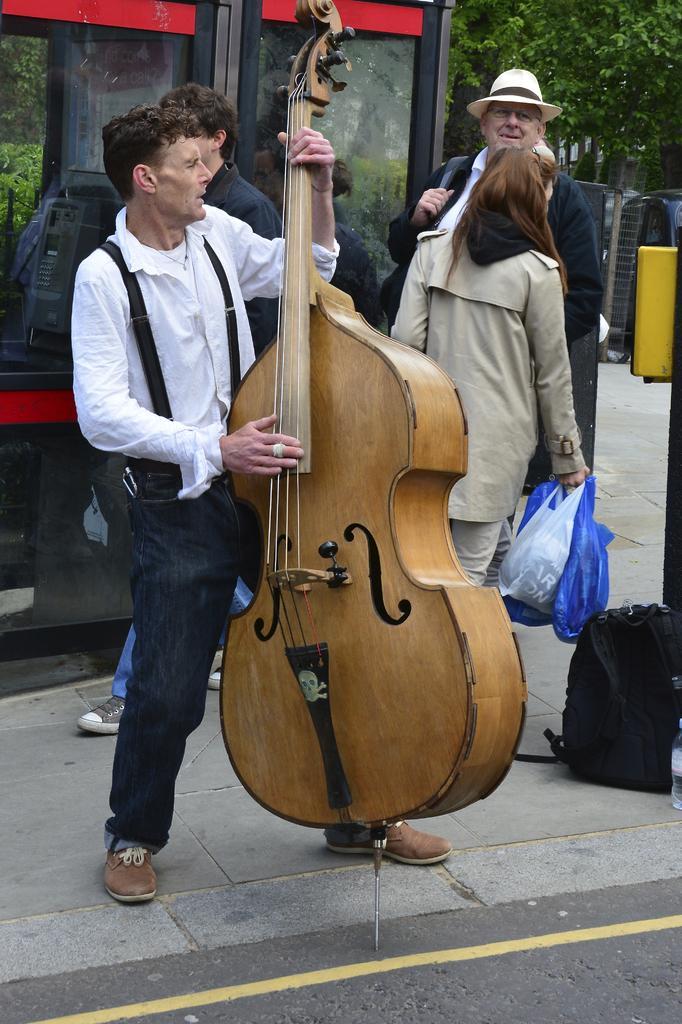Could you give a brief overview of what you see in this image? In this image, we can see a person is playing a musical instrument and standing on the walkway. At the bottom, we can see the road. Background we can see people, glass objects, trees, plants, mesh and few things. Here a woman is holding carry bags. Here there is a backpack on the path. 